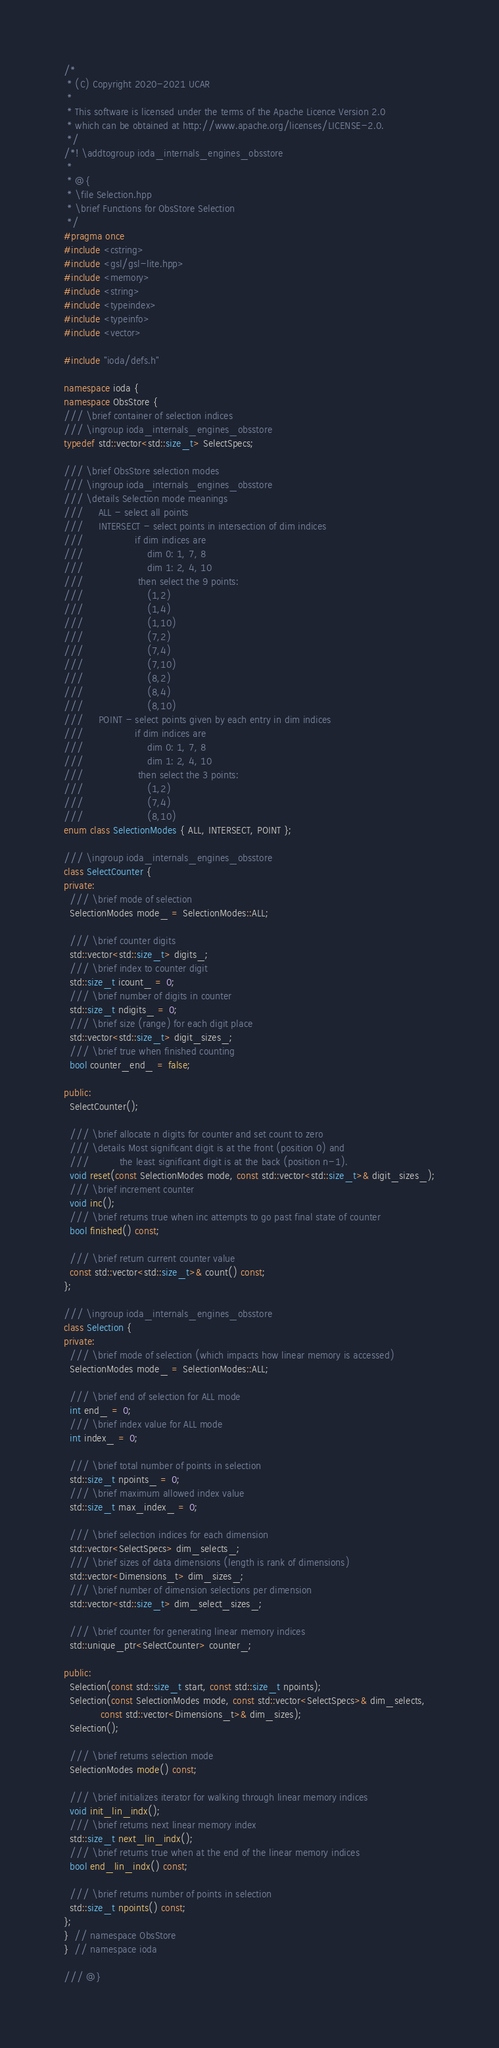Convert code to text. <code><loc_0><loc_0><loc_500><loc_500><_C++_>/*
 * (C) Copyright 2020-2021 UCAR
 *
 * This software is licensed under the terms of the Apache Licence Version 2.0
 * which can be obtained at http://www.apache.org/licenses/LICENSE-2.0.
 */
/*! \addtogroup ioda_internals_engines_obsstore
 *
 * @{
 * \file Selection.hpp
 * \brief Functions for ObsStore Selection
 */
#pragma once
#include <cstring>
#include <gsl/gsl-lite.hpp>
#include <memory>
#include <string>
#include <typeindex>
#include <typeinfo>
#include <vector>

#include "ioda/defs.h"

namespace ioda {
namespace ObsStore {
/// \brief container of selection indices
/// \ingroup ioda_internals_engines_obsstore
typedef std::vector<std::size_t> SelectSpecs;

/// \brief ObsStore selection modes
/// \ingroup ioda_internals_engines_obsstore
/// \details Selection mode meanings
///     ALL - select all points
///     INTERSECT - select points in intersection of dim indices
///                 if dim indices are
///                     dim 0: 1, 7, 8
///                     dim 1: 2, 4, 10
///                  then select the 9 points:
///                     (1,2)
///                     (1,4)
///                     (1,10)
///                     (7,2)
///                     (7,4)
///                     (7,10)
///                     (8,2)
///                     (8,4)
///                     (8,10)
///     POINT - select points given by each entry in dim indices
///                 if dim indices are
///                     dim 0: 1, 7, 8
///                     dim 1: 2, 4, 10
///                  then select the 3 points:
///                     (1,2)
///                     (7,4)
///                     (8,10)
enum class SelectionModes { ALL, INTERSECT, POINT };

/// \ingroup ioda_internals_engines_obsstore
class SelectCounter {
private:
  /// \brief mode of selection
  SelectionModes mode_ = SelectionModes::ALL;

  /// \brief counter digits
  std::vector<std::size_t> digits_;
  /// \brief index to counter digit
  std::size_t icount_ = 0;
  /// \brief number of digits in counter
  std::size_t ndigits_ = 0;
  /// \brief size (range) for each digit place
  std::vector<std::size_t> digit_sizes_;
  /// \brief true when finished counting
  bool counter_end_ = false;

public:
  SelectCounter();

  /// \brief allocate n digits for counter and set count to zero
  /// \details Most significant digit is at the front (position 0) and
  ///          the least significant digit is at the back (position n-1).
  void reset(const SelectionModes mode, const std::vector<std::size_t>& digit_sizes_);
  /// \brief increment counter
  void inc();
  /// \brief returns true when inc attempts to go past final state of counter
  bool finished() const;

  /// \brief return current counter value
  const std::vector<std::size_t>& count() const;
};

/// \ingroup ioda_internals_engines_obsstore
class Selection {
private:
  /// \brief mode of selection (which impacts how linear memory is accessed)
  SelectionModes mode_ = SelectionModes::ALL;

  /// \brief end of selection for ALL mode
  int end_ = 0;
  /// \brief index value for ALL mode
  int index_ = 0;

  /// \brief total number of points in selection
  std::size_t npoints_ = 0;
  /// \brief maximum allowed index value
  std::size_t max_index_ = 0;

  /// \brief selection indices for each dimension
  std::vector<SelectSpecs> dim_selects_;
  /// \brief sizes of data dimensions (length is rank of dimensions)
  std::vector<Dimensions_t> dim_sizes_;
  /// \brief number of dimension selections per dimension
  std::vector<std::size_t> dim_select_sizes_;

  /// \brief counter for generating linear memory indices
  std::unique_ptr<SelectCounter> counter_;

public:
  Selection(const std::size_t start, const std::size_t npoints);
  Selection(const SelectionModes mode, const std::vector<SelectSpecs>& dim_selects,
            const std::vector<Dimensions_t>& dim_sizes);
  Selection();

  /// \brief returns selection mode
  SelectionModes mode() const;

  /// \brief initializes iterator for walking through linear memory indices
  void init_lin_indx();
  /// \brief returns next linear memory index
  std::size_t next_lin_indx();
  /// \brief returns true when at the end of the linear memory indices
  bool end_lin_indx() const;

  /// \brief returns number of points in selection
  std::size_t npoints() const;
};
}  // namespace ObsStore
}  // namespace ioda

/// @}
</code> 